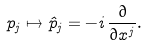<formula> <loc_0><loc_0><loc_500><loc_500>p _ { j } \mapsto \hat { p } _ { j } = - i \, \frac { \partial } { \partial x ^ { j } } .</formula> 